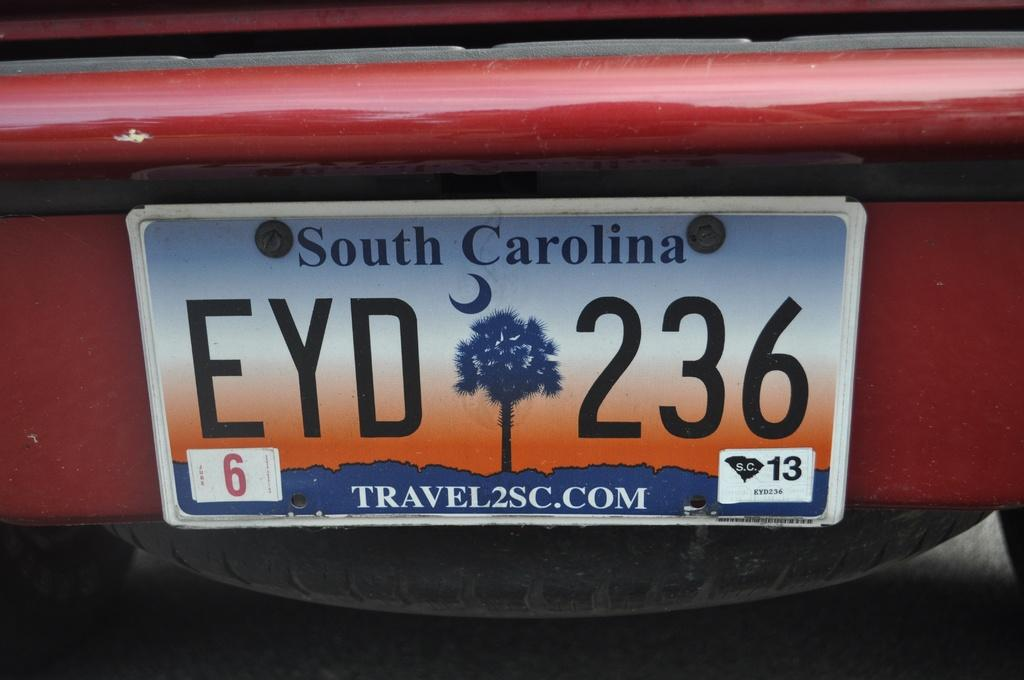<image>
Provide a brief description of the given image. A red vehicle from South Carolina has the license plate number EYD 236. 